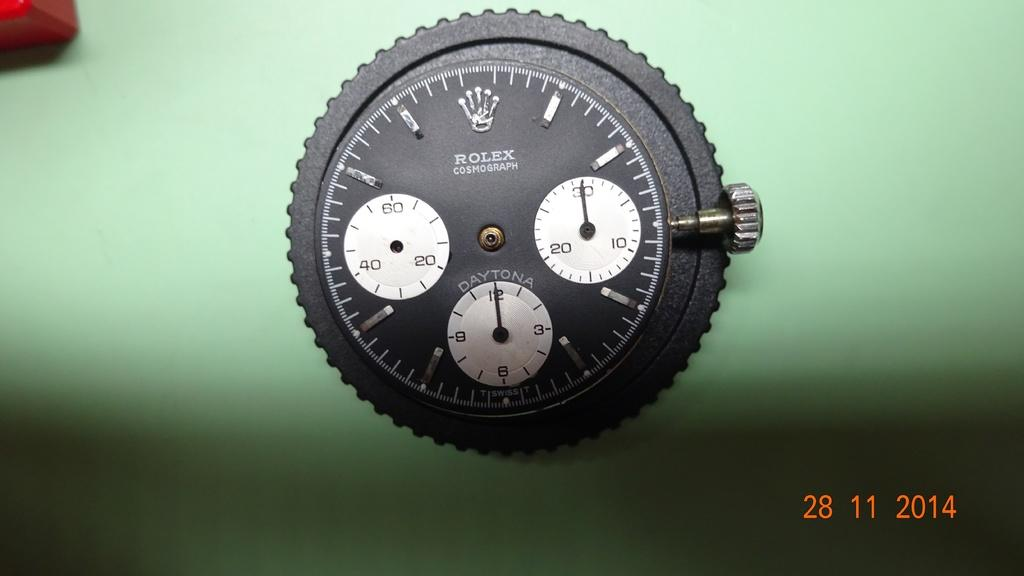<image>
Offer a succinct explanation of the picture presented. A black Rolex stop watch is seen close up against a green background. 